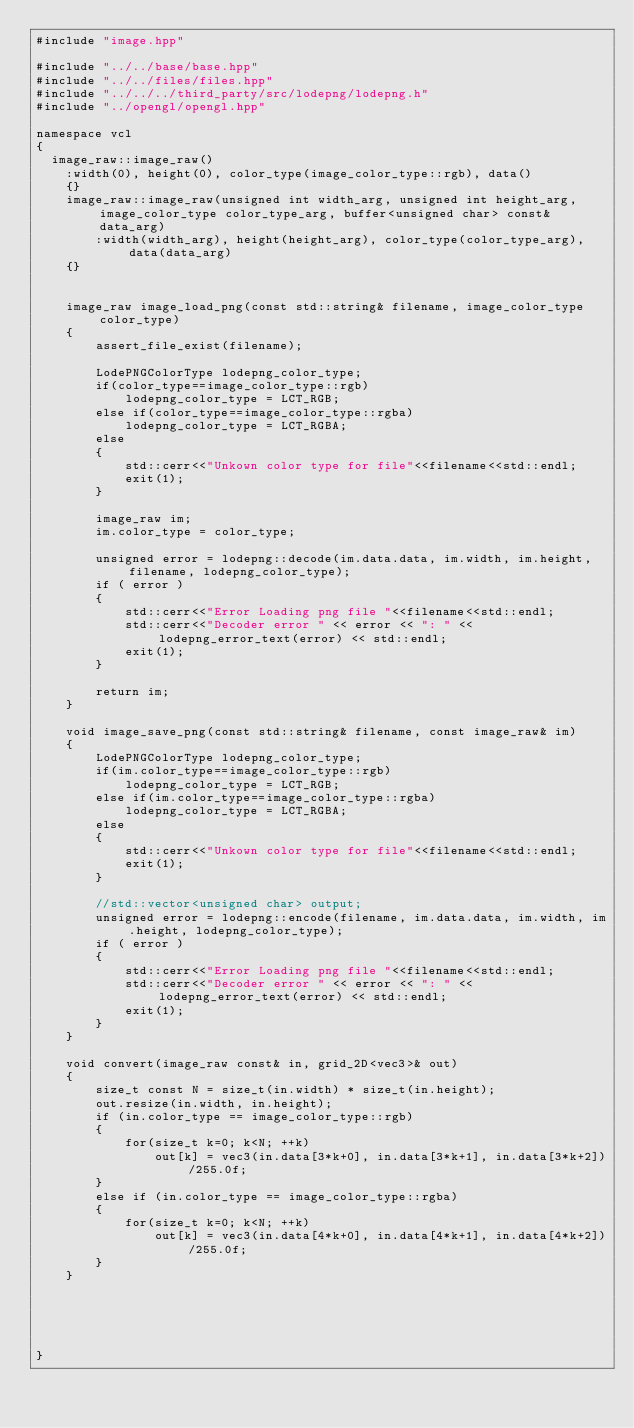<code> <loc_0><loc_0><loc_500><loc_500><_C++_>#include "image.hpp"

#include "../../base/base.hpp"
#include "../../files/files.hpp"
#include "../../../third_party/src/lodepng/lodepng.h"
#include "../opengl/opengl.hpp"

namespace vcl
{
	image_raw::image_raw()
    :width(0), height(0), color_type(image_color_type::rgb), data()
    {}
    image_raw::image_raw(unsigned int width_arg, unsigned int height_arg, image_color_type color_type_arg, buffer<unsigned char> const& data_arg)
        :width(width_arg), height(height_arg), color_type(color_type_arg), data(data_arg)
    {}


    image_raw image_load_png(const std::string& filename, image_color_type color_type)
    {
        assert_file_exist(filename);

        LodePNGColorType lodepng_color_type;
        if(color_type==image_color_type::rgb)
            lodepng_color_type = LCT_RGB;
        else if(color_type==image_color_type::rgba)
            lodepng_color_type = LCT_RGBA;
        else
        {
            std::cerr<<"Unkown color type for file"<<filename<<std::endl;
            exit(1);
        }

        image_raw im;
        im.color_type = color_type;

        unsigned error = lodepng::decode(im.data.data, im.width, im.height, filename, lodepng_color_type);
        if ( error )
        {
            std::cerr<<"Error Loading png file "<<filename<<std::endl;
            std::cerr<<"Decoder error " << error << ": " << lodepng_error_text(error) << std::endl;
            exit(1);
        }

        return im;
    }

    void image_save_png(const std::string& filename, const image_raw& im)
    {
        LodePNGColorType lodepng_color_type;
        if(im.color_type==image_color_type::rgb)
            lodepng_color_type = LCT_RGB;
        else if(im.color_type==image_color_type::rgba)
            lodepng_color_type = LCT_RGBA;
        else
        {
            std::cerr<<"Unkown color type for file"<<filename<<std::endl;
            exit(1);
        }

        //std::vector<unsigned char> output;
        unsigned error = lodepng::encode(filename, im.data.data, im.width, im.height, lodepng_color_type);
        if ( error )
        {
            std::cerr<<"Error Loading png file "<<filename<<std::endl;
            std::cerr<<"Decoder error " << error << ": " << lodepng_error_text(error) << std::endl;
            exit(1);
        }
    }

    void convert(image_raw const& in, grid_2D<vec3>& out)
    {
        size_t const N = size_t(in.width) * size_t(in.height);
        out.resize(in.width, in.height);
        if (in.color_type == image_color_type::rgb)
        {
            for(size_t k=0; k<N; ++k)
                out[k] = vec3(in.data[3*k+0], in.data[3*k+1], in.data[3*k+2])/255.0f;
        }
        else if (in.color_type == image_color_type::rgba)
        {
            for(size_t k=0; k<N; ++k)
                out[k] = vec3(in.data[4*k+0], in.data[4*k+1], in.data[4*k+2])/255.0f;
        }
    }





}
</code> 